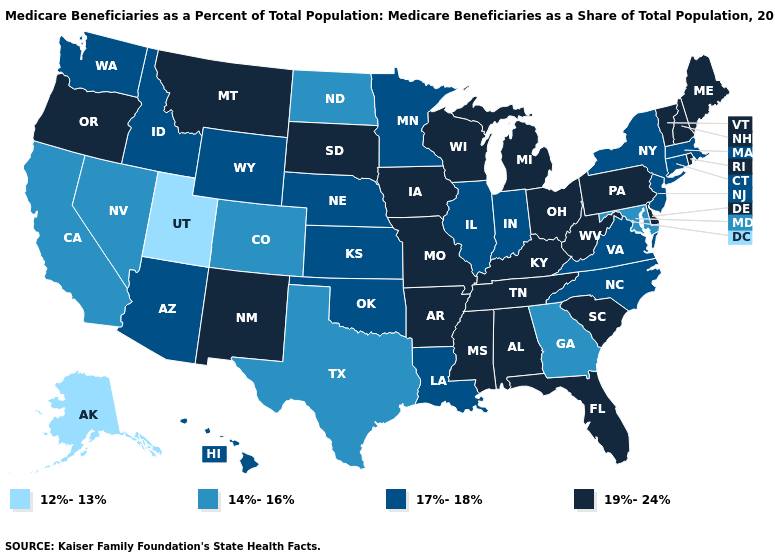What is the value of New Jersey?
Be succinct. 17%-18%. Name the states that have a value in the range 14%-16%?
Be succinct. California, Colorado, Georgia, Maryland, Nevada, North Dakota, Texas. Which states have the highest value in the USA?
Write a very short answer. Alabama, Arkansas, Delaware, Florida, Iowa, Kentucky, Maine, Michigan, Mississippi, Missouri, Montana, New Hampshire, New Mexico, Ohio, Oregon, Pennsylvania, Rhode Island, South Carolina, South Dakota, Tennessee, Vermont, West Virginia, Wisconsin. Which states hav the highest value in the MidWest?
Answer briefly. Iowa, Michigan, Missouri, Ohio, South Dakota, Wisconsin. Among the states that border Illinois , which have the lowest value?
Answer briefly. Indiana. Name the states that have a value in the range 14%-16%?
Give a very brief answer. California, Colorado, Georgia, Maryland, Nevada, North Dakota, Texas. Does the map have missing data?
Give a very brief answer. No. What is the highest value in states that border Montana?
Write a very short answer. 19%-24%. What is the value of Michigan?
Quick response, please. 19%-24%. What is the value of Wyoming?
Short answer required. 17%-18%. Is the legend a continuous bar?
Concise answer only. No. Name the states that have a value in the range 17%-18%?
Be succinct. Arizona, Connecticut, Hawaii, Idaho, Illinois, Indiana, Kansas, Louisiana, Massachusetts, Minnesota, Nebraska, New Jersey, New York, North Carolina, Oklahoma, Virginia, Washington, Wyoming. What is the lowest value in the MidWest?
Give a very brief answer. 14%-16%. Among the states that border South Dakota , which have the highest value?
Answer briefly. Iowa, Montana. What is the highest value in the USA?
Short answer required. 19%-24%. 